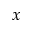<formula> <loc_0><loc_0><loc_500><loc_500>x</formula> 